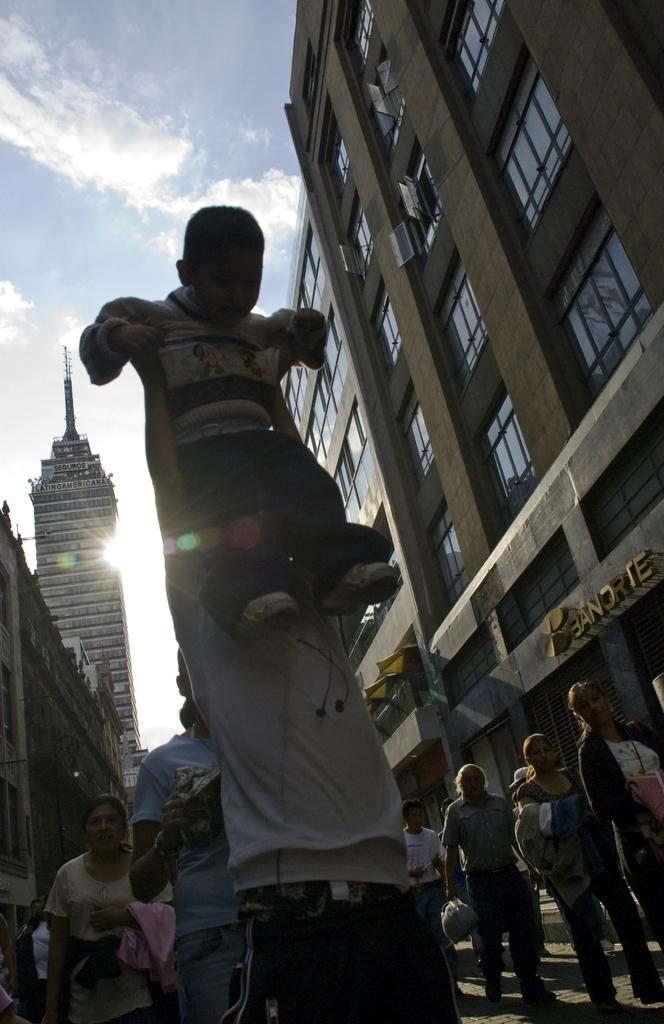What are the people in the image doing? There is a group of people standing on the road. Can you describe the interaction between one of the people and a child? One person is holding a child. What can be seen in the background of the image? There are buildings in the background of the image, along with the sun and sky. Where is the kettle placed in the image? There is no kettle present in the image. What type of food is served on the plate in the image? There is no plate present in the image. 